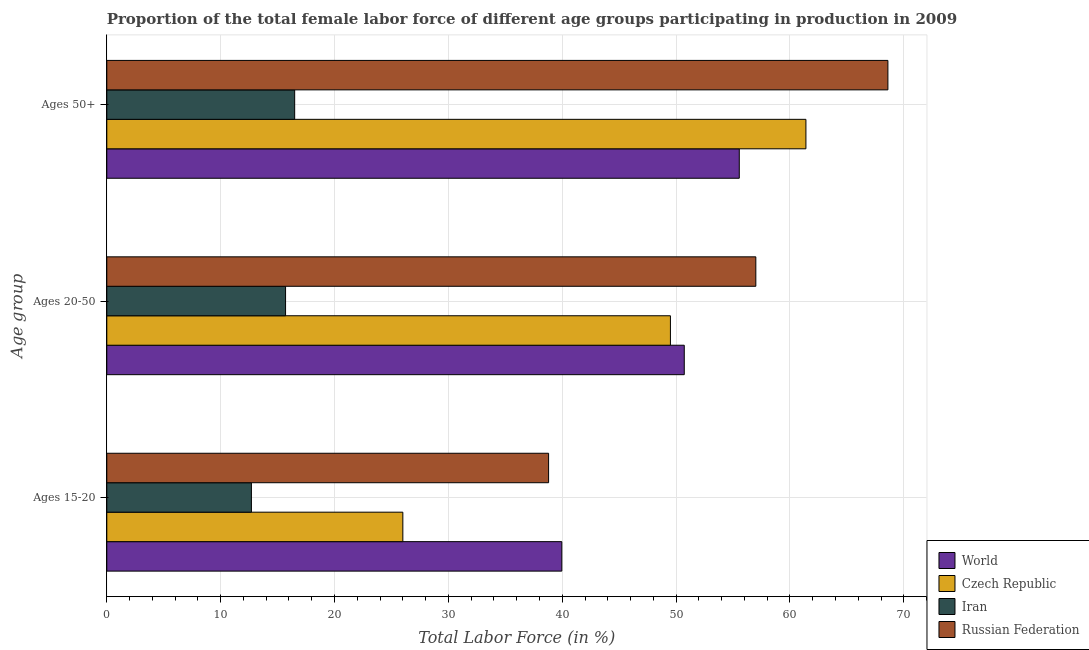Are the number of bars per tick equal to the number of legend labels?
Give a very brief answer. Yes. Are the number of bars on each tick of the Y-axis equal?
Offer a terse response. Yes. How many bars are there on the 3rd tick from the top?
Ensure brevity in your answer.  4. How many bars are there on the 3rd tick from the bottom?
Your answer should be very brief. 4. What is the label of the 3rd group of bars from the top?
Keep it short and to the point. Ages 15-20. What is the percentage of female labor force within the age group 20-50 in World?
Your response must be concise. 50.72. Across all countries, what is the maximum percentage of female labor force within the age group 15-20?
Your answer should be very brief. 39.96. Across all countries, what is the minimum percentage of female labor force within the age group 20-50?
Keep it short and to the point. 15.7. In which country was the percentage of female labor force above age 50 maximum?
Provide a succinct answer. Russian Federation. In which country was the percentage of female labor force within the age group 20-50 minimum?
Your response must be concise. Iran. What is the total percentage of female labor force above age 50 in the graph?
Your response must be concise. 202.05. What is the difference between the percentage of female labor force within the age group 20-50 in Russian Federation and that in Iran?
Your answer should be compact. 41.3. What is the difference between the percentage of female labor force above age 50 in World and the percentage of female labor force within the age group 15-20 in Czech Republic?
Your response must be concise. 29.55. What is the average percentage of female labor force within the age group 15-20 per country?
Offer a terse response. 29.37. What is the difference between the percentage of female labor force above age 50 and percentage of female labor force within the age group 15-20 in Russian Federation?
Provide a short and direct response. 29.8. In how many countries, is the percentage of female labor force within the age group 15-20 greater than 56 %?
Ensure brevity in your answer.  0. What is the ratio of the percentage of female labor force within the age group 20-50 in World to that in Czech Republic?
Keep it short and to the point. 1.02. Is the difference between the percentage of female labor force above age 50 in Iran and Czech Republic greater than the difference between the percentage of female labor force within the age group 15-20 in Iran and Czech Republic?
Your response must be concise. No. What is the difference between the highest and the second highest percentage of female labor force within the age group 20-50?
Make the answer very short. 6.28. What is the difference between the highest and the lowest percentage of female labor force within the age group 20-50?
Ensure brevity in your answer.  41.3. In how many countries, is the percentage of female labor force within the age group 20-50 greater than the average percentage of female labor force within the age group 20-50 taken over all countries?
Offer a very short reply. 3. What does the 2nd bar from the top in Ages 20-50 represents?
Provide a short and direct response. Iran. How many bars are there?
Keep it short and to the point. 12. Are all the bars in the graph horizontal?
Ensure brevity in your answer.  Yes. How many countries are there in the graph?
Make the answer very short. 4. What is the difference between two consecutive major ticks on the X-axis?
Provide a short and direct response. 10. Does the graph contain any zero values?
Ensure brevity in your answer.  No. Where does the legend appear in the graph?
Make the answer very short. Bottom right. How many legend labels are there?
Keep it short and to the point. 4. What is the title of the graph?
Provide a short and direct response. Proportion of the total female labor force of different age groups participating in production in 2009. What is the label or title of the Y-axis?
Make the answer very short. Age group. What is the Total Labor Force (in %) of World in Ages 15-20?
Provide a short and direct response. 39.96. What is the Total Labor Force (in %) in Czech Republic in Ages 15-20?
Make the answer very short. 26. What is the Total Labor Force (in %) of Iran in Ages 15-20?
Your answer should be very brief. 12.7. What is the Total Labor Force (in %) in Russian Federation in Ages 15-20?
Ensure brevity in your answer.  38.8. What is the Total Labor Force (in %) of World in Ages 20-50?
Your answer should be compact. 50.72. What is the Total Labor Force (in %) of Czech Republic in Ages 20-50?
Provide a succinct answer. 49.5. What is the Total Labor Force (in %) of Iran in Ages 20-50?
Keep it short and to the point. 15.7. What is the Total Labor Force (in %) in World in Ages 50+?
Keep it short and to the point. 55.55. What is the Total Labor Force (in %) of Czech Republic in Ages 50+?
Offer a very short reply. 61.4. What is the Total Labor Force (in %) in Iran in Ages 50+?
Your answer should be very brief. 16.5. What is the Total Labor Force (in %) in Russian Federation in Ages 50+?
Offer a terse response. 68.6. Across all Age group, what is the maximum Total Labor Force (in %) of World?
Your answer should be very brief. 55.55. Across all Age group, what is the maximum Total Labor Force (in %) of Czech Republic?
Ensure brevity in your answer.  61.4. Across all Age group, what is the maximum Total Labor Force (in %) in Iran?
Provide a short and direct response. 16.5. Across all Age group, what is the maximum Total Labor Force (in %) in Russian Federation?
Your answer should be compact. 68.6. Across all Age group, what is the minimum Total Labor Force (in %) in World?
Your response must be concise. 39.96. Across all Age group, what is the minimum Total Labor Force (in %) in Iran?
Ensure brevity in your answer.  12.7. Across all Age group, what is the minimum Total Labor Force (in %) of Russian Federation?
Keep it short and to the point. 38.8. What is the total Total Labor Force (in %) of World in the graph?
Provide a short and direct response. 146.22. What is the total Total Labor Force (in %) in Czech Republic in the graph?
Your response must be concise. 136.9. What is the total Total Labor Force (in %) of Iran in the graph?
Ensure brevity in your answer.  44.9. What is the total Total Labor Force (in %) of Russian Federation in the graph?
Ensure brevity in your answer.  164.4. What is the difference between the Total Labor Force (in %) in World in Ages 15-20 and that in Ages 20-50?
Ensure brevity in your answer.  -10.75. What is the difference between the Total Labor Force (in %) in Czech Republic in Ages 15-20 and that in Ages 20-50?
Keep it short and to the point. -23.5. What is the difference between the Total Labor Force (in %) of Iran in Ages 15-20 and that in Ages 20-50?
Your answer should be very brief. -3. What is the difference between the Total Labor Force (in %) in Russian Federation in Ages 15-20 and that in Ages 20-50?
Offer a terse response. -18.2. What is the difference between the Total Labor Force (in %) of World in Ages 15-20 and that in Ages 50+?
Make the answer very short. -15.59. What is the difference between the Total Labor Force (in %) of Czech Republic in Ages 15-20 and that in Ages 50+?
Provide a short and direct response. -35.4. What is the difference between the Total Labor Force (in %) in Russian Federation in Ages 15-20 and that in Ages 50+?
Ensure brevity in your answer.  -29.8. What is the difference between the Total Labor Force (in %) of World in Ages 20-50 and that in Ages 50+?
Keep it short and to the point. -4.83. What is the difference between the Total Labor Force (in %) in Czech Republic in Ages 20-50 and that in Ages 50+?
Offer a very short reply. -11.9. What is the difference between the Total Labor Force (in %) in World in Ages 15-20 and the Total Labor Force (in %) in Czech Republic in Ages 20-50?
Offer a terse response. -9.54. What is the difference between the Total Labor Force (in %) in World in Ages 15-20 and the Total Labor Force (in %) in Iran in Ages 20-50?
Provide a short and direct response. 24.26. What is the difference between the Total Labor Force (in %) of World in Ages 15-20 and the Total Labor Force (in %) of Russian Federation in Ages 20-50?
Your answer should be compact. -17.04. What is the difference between the Total Labor Force (in %) of Czech Republic in Ages 15-20 and the Total Labor Force (in %) of Iran in Ages 20-50?
Provide a succinct answer. 10.3. What is the difference between the Total Labor Force (in %) of Czech Republic in Ages 15-20 and the Total Labor Force (in %) of Russian Federation in Ages 20-50?
Provide a short and direct response. -31. What is the difference between the Total Labor Force (in %) in Iran in Ages 15-20 and the Total Labor Force (in %) in Russian Federation in Ages 20-50?
Offer a terse response. -44.3. What is the difference between the Total Labor Force (in %) of World in Ages 15-20 and the Total Labor Force (in %) of Czech Republic in Ages 50+?
Provide a short and direct response. -21.44. What is the difference between the Total Labor Force (in %) of World in Ages 15-20 and the Total Labor Force (in %) of Iran in Ages 50+?
Ensure brevity in your answer.  23.46. What is the difference between the Total Labor Force (in %) in World in Ages 15-20 and the Total Labor Force (in %) in Russian Federation in Ages 50+?
Your answer should be very brief. -28.64. What is the difference between the Total Labor Force (in %) in Czech Republic in Ages 15-20 and the Total Labor Force (in %) in Russian Federation in Ages 50+?
Offer a terse response. -42.6. What is the difference between the Total Labor Force (in %) in Iran in Ages 15-20 and the Total Labor Force (in %) in Russian Federation in Ages 50+?
Offer a very short reply. -55.9. What is the difference between the Total Labor Force (in %) of World in Ages 20-50 and the Total Labor Force (in %) of Czech Republic in Ages 50+?
Keep it short and to the point. -10.68. What is the difference between the Total Labor Force (in %) of World in Ages 20-50 and the Total Labor Force (in %) of Iran in Ages 50+?
Ensure brevity in your answer.  34.22. What is the difference between the Total Labor Force (in %) of World in Ages 20-50 and the Total Labor Force (in %) of Russian Federation in Ages 50+?
Ensure brevity in your answer.  -17.88. What is the difference between the Total Labor Force (in %) in Czech Republic in Ages 20-50 and the Total Labor Force (in %) in Russian Federation in Ages 50+?
Provide a succinct answer. -19.1. What is the difference between the Total Labor Force (in %) of Iran in Ages 20-50 and the Total Labor Force (in %) of Russian Federation in Ages 50+?
Your answer should be very brief. -52.9. What is the average Total Labor Force (in %) of World per Age group?
Your answer should be very brief. 48.74. What is the average Total Labor Force (in %) of Czech Republic per Age group?
Your answer should be very brief. 45.63. What is the average Total Labor Force (in %) in Iran per Age group?
Keep it short and to the point. 14.97. What is the average Total Labor Force (in %) of Russian Federation per Age group?
Offer a very short reply. 54.8. What is the difference between the Total Labor Force (in %) in World and Total Labor Force (in %) in Czech Republic in Ages 15-20?
Ensure brevity in your answer.  13.96. What is the difference between the Total Labor Force (in %) in World and Total Labor Force (in %) in Iran in Ages 15-20?
Make the answer very short. 27.26. What is the difference between the Total Labor Force (in %) in World and Total Labor Force (in %) in Russian Federation in Ages 15-20?
Offer a very short reply. 1.16. What is the difference between the Total Labor Force (in %) in Czech Republic and Total Labor Force (in %) in Iran in Ages 15-20?
Provide a short and direct response. 13.3. What is the difference between the Total Labor Force (in %) of Czech Republic and Total Labor Force (in %) of Russian Federation in Ages 15-20?
Offer a terse response. -12.8. What is the difference between the Total Labor Force (in %) of Iran and Total Labor Force (in %) of Russian Federation in Ages 15-20?
Your answer should be very brief. -26.1. What is the difference between the Total Labor Force (in %) of World and Total Labor Force (in %) of Czech Republic in Ages 20-50?
Offer a very short reply. 1.22. What is the difference between the Total Labor Force (in %) in World and Total Labor Force (in %) in Iran in Ages 20-50?
Your answer should be very brief. 35.02. What is the difference between the Total Labor Force (in %) in World and Total Labor Force (in %) in Russian Federation in Ages 20-50?
Your response must be concise. -6.28. What is the difference between the Total Labor Force (in %) in Czech Republic and Total Labor Force (in %) in Iran in Ages 20-50?
Keep it short and to the point. 33.8. What is the difference between the Total Labor Force (in %) in Czech Republic and Total Labor Force (in %) in Russian Federation in Ages 20-50?
Offer a very short reply. -7.5. What is the difference between the Total Labor Force (in %) in Iran and Total Labor Force (in %) in Russian Federation in Ages 20-50?
Keep it short and to the point. -41.3. What is the difference between the Total Labor Force (in %) of World and Total Labor Force (in %) of Czech Republic in Ages 50+?
Make the answer very short. -5.85. What is the difference between the Total Labor Force (in %) in World and Total Labor Force (in %) in Iran in Ages 50+?
Your answer should be very brief. 39.05. What is the difference between the Total Labor Force (in %) of World and Total Labor Force (in %) of Russian Federation in Ages 50+?
Provide a succinct answer. -13.05. What is the difference between the Total Labor Force (in %) of Czech Republic and Total Labor Force (in %) of Iran in Ages 50+?
Ensure brevity in your answer.  44.9. What is the difference between the Total Labor Force (in %) in Iran and Total Labor Force (in %) in Russian Federation in Ages 50+?
Give a very brief answer. -52.1. What is the ratio of the Total Labor Force (in %) of World in Ages 15-20 to that in Ages 20-50?
Keep it short and to the point. 0.79. What is the ratio of the Total Labor Force (in %) of Czech Republic in Ages 15-20 to that in Ages 20-50?
Offer a terse response. 0.53. What is the ratio of the Total Labor Force (in %) in Iran in Ages 15-20 to that in Ages 20-50?
Offer a very short reply. 0.81. What is the ratio of the Total Labor Force (in %) in Russian Federation in Ages 15-20 to that in Ages 20-50?
Provide a short and direct response. 0.68. What is the ratio of the Total Labor Force (in %) in World in Ages 15-20 to that in Ages 50+?
Provide a succinct answer. 0.72. What is the ratio of the Total Labor Force (in %) in Czech Republic in Ages 15-20 to that in Ages 50+?
Give a very brief answer. 0.42. What is the ratio of the Total Labor Force (in %) in Iran in Ages 15-20 to that in Ages 50+?
Ensure brevity in your answer.  0.77. What is the ratio of the Total Labor Force (in %) of Russian Federation in Ages 15-20 to that in Ages 50+?
Provide a succinct answer. 0.57. What is the ratio of the Total Labor Force (in %) of Czech Republic in Ages 20-50 to that in Ages 50+?
Keep it short and to the point. 0.81. What is the ratio of the Total Labor Force (in %) in Iran in Ages 20-50 to that in Ages 50+?
Give a very brief answer. 0.95. What is the ratio of the Total Labor Force (in %) of Russian Federation in Ages 20-50 to that in Ages 50+?
Give a very brief answer. 0.83. What is the difference between the highest and the second highest Total Labor Force (in %) in World?
Make the answer very short. 4.83. What is the difference between the highest and the second highest Total Labor Force (in %) of Iran?
Keep it short and to the point. 0.8. What is the difference between the highest and the second highest Total Labor Force (in %) of Russian Federation?
Your answer should be very brief. 11.6. What is the difference between the highest and the lowest Total Labor Force (in %) in World?
Offer a very short reply. 15.59. What is the difference between the highest and the lowest Total Labor Force (in %) of Czech Republic?
Provide a succinct answer. 35.4. What is the difference between the highest and the lowest Total Labor Force (in %) of Russian Federation?
Ensure brevity in your answer.  29.8. 